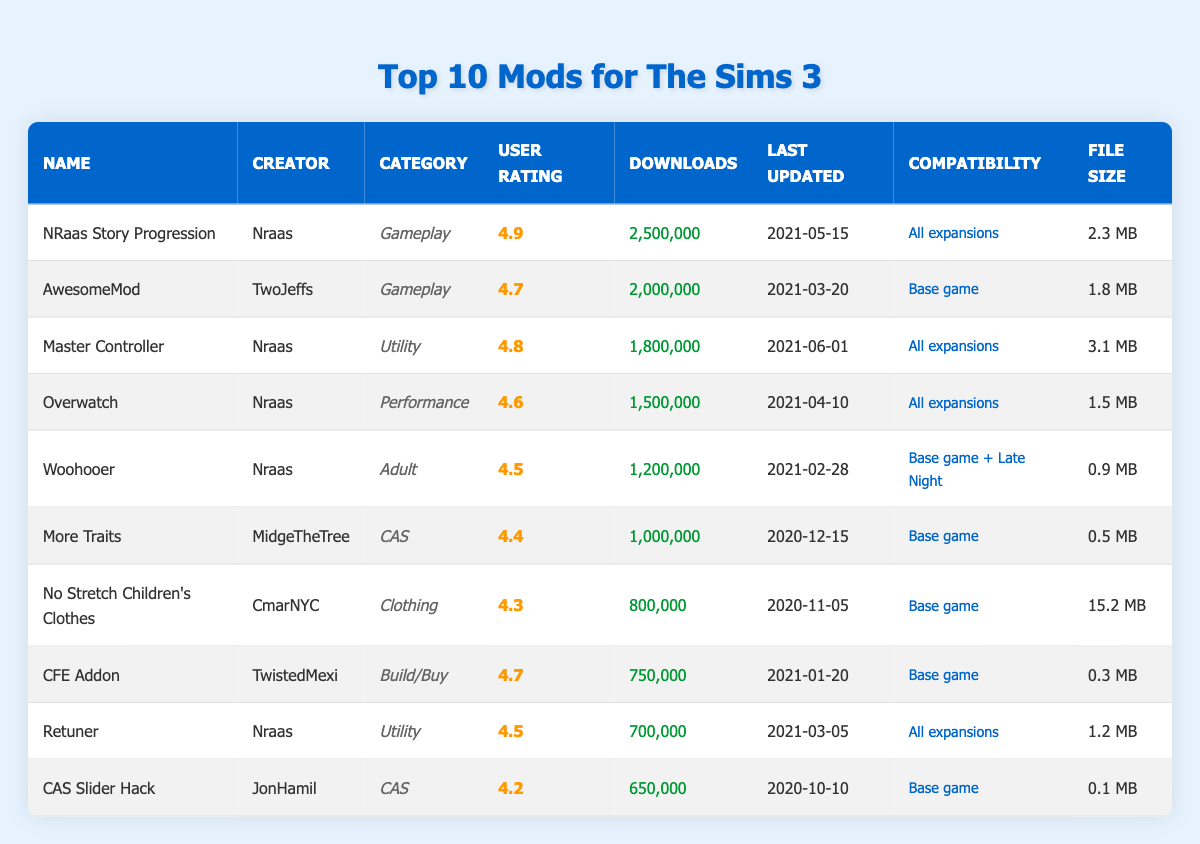What is the user rating of NRaas Story Progression? The user rating for NRaas Story Progression is listed directly in the table under the 'User Rating' column, which shows a value of 4.9.
Answer: 4.9 Which mod has the highest number of downloads? By comparing the 'Downloads' column, NRaas Story Progression has 2,500,000 downloads, which is the highest among all listed mods.
Answer: NRaas Story Progression Is the AwesomeMod compatible with all expansions? Looking at the 'Compatibility' column, AwesomeMod is listed as compatible only with the Base game, not all expansions.
Answer: No What is the average user rating of the top three mods? The user ratings of the top three mods (NRaas Story Progression, Master Controller, and AwesomeMod) are 4.9, 4.8, and 4.7 respectively. Adding these gives 14.4, and dividing by 3 results in an average of 4.8.
Answer: 4.8 How many mods in the table require the Base game only? Upon reviewing the 'Compatibility' column, three mods (AwesomeMod, More Traits, and No Stretch Children's Clothes) specifically require the Base game only.
Answer: 3 Which creator has the most mods listed in the table? By analyzing the 'Creator' column, Nraas appears four times for NRaas Story Progression, Master Controller, Overwatch, and Woohooer, making it the creator with the most mods.
Answer: Nraas What mod was last updated on 2021-03-20? Referring to the 'Last Updated' column, AwesomeMod is the mod listed with that specific update date.
Answer: AwesomeMod What is the combined file size of the top two mods? The file sizes of the top two mods, NRaas Story Progression (2.3 MB) and Master Controller (3.1 MB), add up to 5.4 MB (2.3 + 3.1).
Answer: 5.4 MB Does the CFE Addon have more downloads than the Retuner? The 'Downloads' column shows CFE Addon has 750,000 downloads and Retuner has 700,000 downloads. Since 750,000 is greater than 700,000, the statement is true.
Answer: Yes 